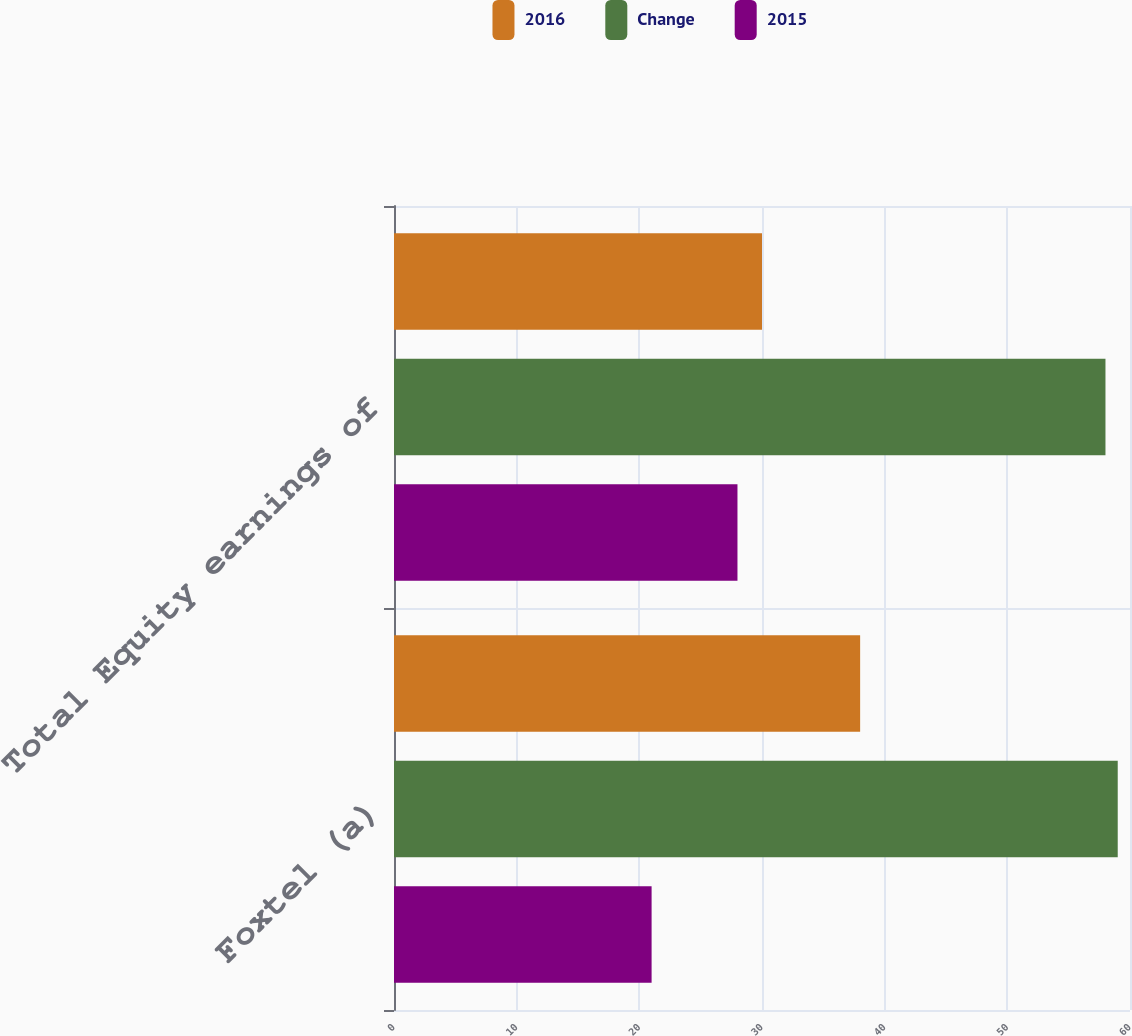<chart> <loc_0><loc_0><loc_500><loc_500><stacked_bar_chart><ecel><fcel>Foxtel (a)<fcel>Total Equity earnings of<nl><fcel>2016<fcel>38<fcel>30<nl><fcel>Change<fcel>59<fcel>58<nl><fcel>2015<fcel>21<fcel>28<nl></chart> 